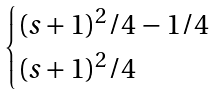Convert formula to latex. <formula><loc_0><loc_0><loc_500><loc_500>\begin{cases} ( s + 1 ) ^ { 2 } / 4 - 1 / 4 \\ ( s + 1 ) ^ { 2 } / 4 \end{cases}</formula> 